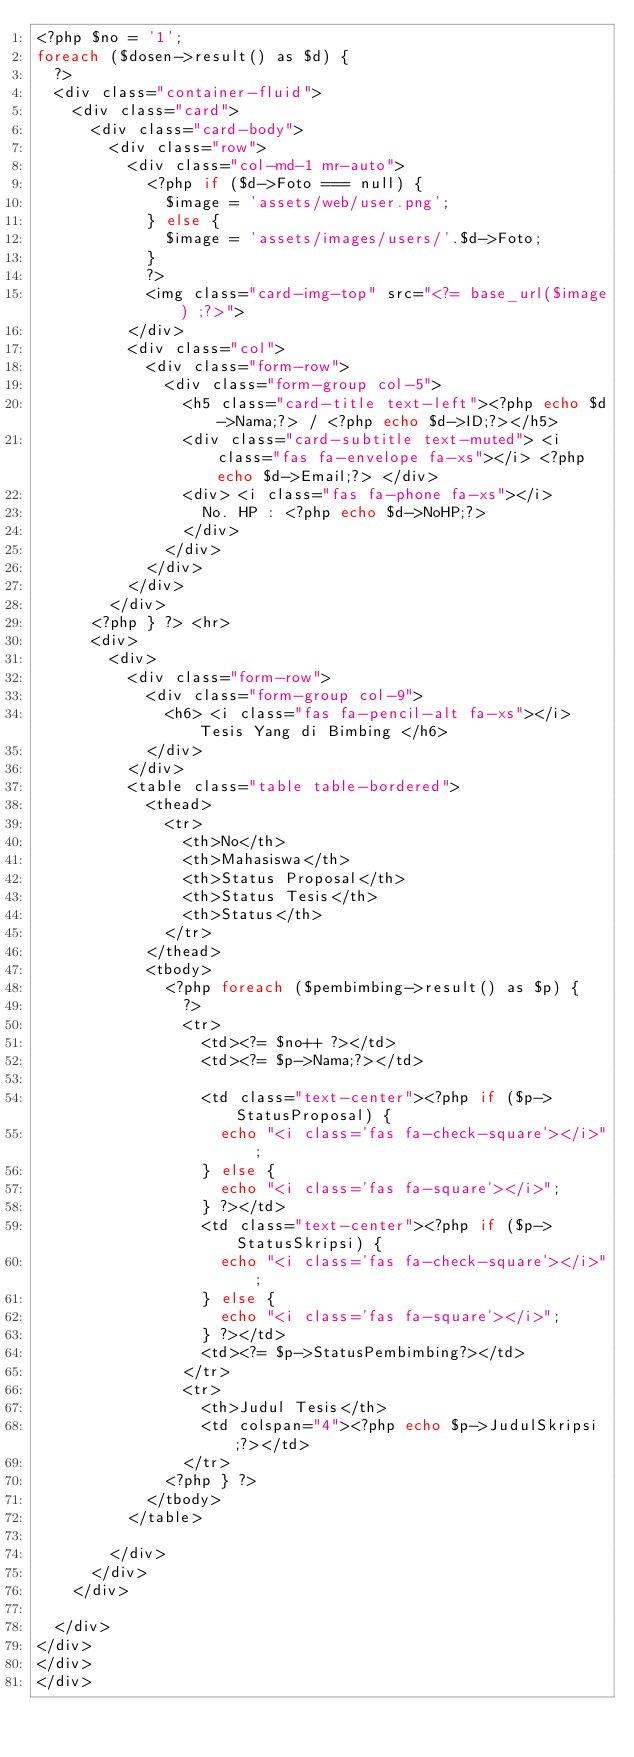Convert code to text. <code><loc_0><loc_0><loc_500><loc_500><_PHP_><?php $no = '1';
foreach ($dosen->result() as $d) {
	?>
	<div class="container-fluid">
		<div class="card">
			<div class="card-body">
				<div class="row">
					<div class="col-md-1 mr-auto">
						<?php if ($d->Foto === null) {
							$image = 'assets/web/user.png';
						} else {
							$image = 'assets/images/users/'.$d->Foto;
						} 
						?>						
						<img class="card-img-top" src="<?= base_url($image) ;?>">
					</div>
					<div class="col">
						<div class="form-row">
							<div class="form-group col-5">
								<h5 class="card-title text-left"><?php echo $d->Nama;?> / <?php echo $d->ID;?></h5>
								<div class="card-subtitle text-muted"> <i class="fas fa-envelope fa-xs"></i> <?php echo $d->Email;?> </div>
								<div> <i class="fas fa-phone fa-xs"></i>
									No. HP : <?php echo $d->NoHP;?> 
								</div>
							</div>						
						</div>
					</div>
				</div>
			<?php } ?> <hr>
			<div>
				<div>
					<div class="form-row">
						<div class="form-group col-9">
							<h6> <i class="fas fa-pencil-alt fa-xs"></i> Tesis Yang di Bimbing </h6>	
						</div>
					</div>
					<table class="table table-bordered">
						<thead>
							<tr>
								<th>No</th>
								<th>Mahasiswa</th>
								<th>Status Proposal</th>
								<th>Status Tesis</th>
								<th>Status</th>
							</tr>
						</thead>
						<tbody>
							<?php foreach ($pembimbing->result() as $p) {
								?>
								<tr>
									<td><?= $no++ ?></td>
									<td><?= $p->Nama;?></td>
									
									<td class="text-center"><?php if ($p->StatusProposal) {
										echo "<i class='fas fa-check-square'></i>";
									} else {
										echo "<i class='fas fa-square'></i>";
									} ?></td>
									<td class="text-center"><?php if ($p->StatusSkripsi) {
										echo "<i class='fas fa-check-square'></i>";
									} else {
										echo "<i class='fas fa-square'></i>";
									} ?></td>
									<td><?= $p->StatusPembimbing?></td>
								</tr>
								<tr>
									<th>Judul Tesis</th>
									<td colspan="4"><?php echo $p->JudulSkripsi;?></td>
								</tr>
							<?php } ?>
						</tbody>
					</table>

				</div>
			</div>
		</div>

	</div>
</div>
</div>
</div></code> 